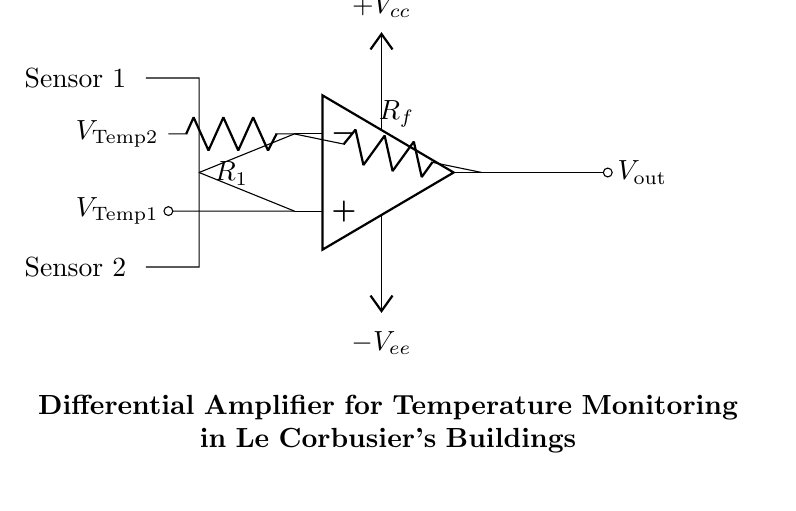What is the type of amplifier used in this circuit? The circuit features an operational amplifier (op amp), which is a common type of amplifier used for various applications, including differential amplifiers.
Answer: Operational amplifier What are the values of the resistors labeled in the circuit? The resistors are labeled as R1 and Rf; without values specified in the circuit diagram, they are typically chosen based on the design requirements.
Answer: R1 and Rf What do the symbols Vcc and Vee represent? Vcc and Vee represent the positive and negative power supply voltages connected to the operational amplifier, respectively.
Answer: Power supply voltages How many temperature sensors are integrated into this circuit? There are two thermistors, labeled as Sensor 1 and Sensor 2, which serve as the temperature sensors in the circuit.
Answer: Two What is the role of the feedback resistor Rf? The feedback resistor Rf is crucial as it controls the gain of the amplifier, determining how much output voltage is amplified from the input voltage difference.
Answer: Controls the gain What happens to the output voltage Vout if the temperature at Sensor 1 increases while the temperature at Sensor 2 remains constant? If the temperature at Sensor 1 increases, the voltage at the non-inverting input will rise, leading to an increase in the output voltage Vout, assuming all other conditions remain stable.
Answer: Vout increases What is the purpose of connecting the thermistors to the operational amplifier? The thermistors are connected to detect temperature variations, which the op amp amplifies for more precise monitoring and control of the temperature in the building environment.
Answer: Temperature monitoring 